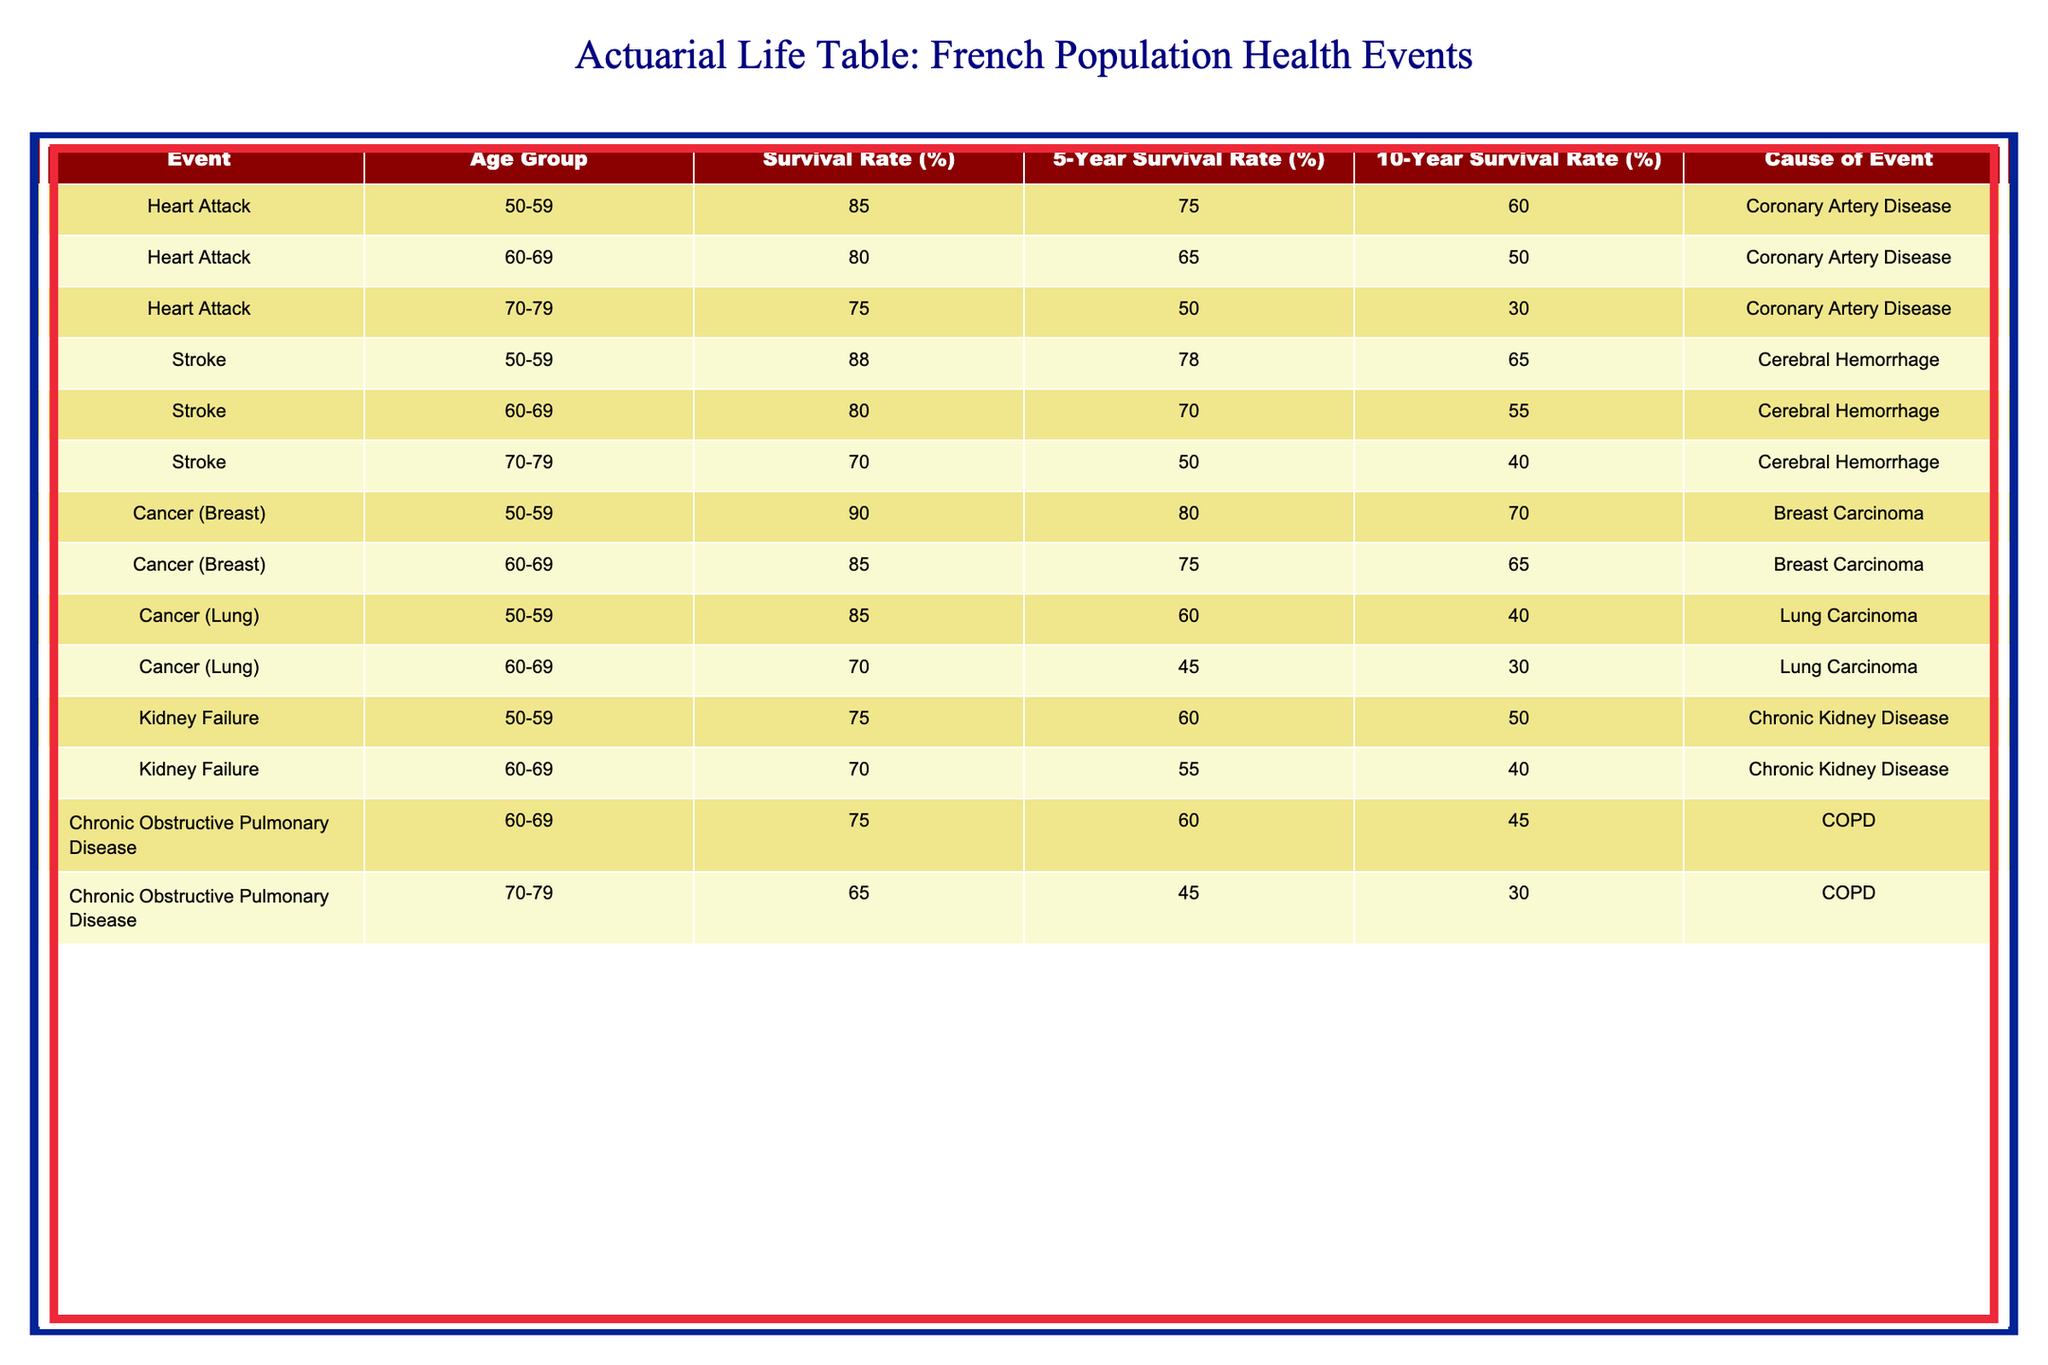What is the survival rate for individuals aged 60-69 after a heart attack? The table shows that the survival rate for individuals aged 60-69 following a heart attack is 80%. This value can be directly retrieved from the relevant row under the "Survival Rate (%)" column.
Answer: 80% What is the 10-year survival rate for individuals aged 50-59 who suffered from lung cancer? According to the table, individuals aged 50-59 who suffered from lung cancer have a 10-year survival rate of 40%. This figure is found in the row dedicated to "Cancer (Lung)" under the 10-Year Survival Rate (%) column related to this age group.
Answer: 40% Is the survival rate for individuals aged 70-79 after a stroke greater than that for kidney failure in the same age group? The survival rate after a stroke for individuals aged 70-79 is 70%, while for kidney failure, it is 65%. Thus, 70% is greater than 65%, making the statement true.
Answer: Yes What is the average 5-year survival rate for individuals aged 50-59 across all health events listed? To find the average 5-year survival rate, we sum the survival rates for age group 50-59: 75% (Heart Attack) + 78% (Stroke) + 80% (Cancer - Breast) + 60% (Cancer - Lung) + 60% (Kidney Failure) = 353%. Dividing this by the number of events (5) gives us an average of 70.6%.
Answer: 70.6% What is the survival rate for individuals aged 60-69 after stroke compared to cancer (breast) in the same age group? The survival rate after a stroke for individuals aged 60-69 is 80%, while the survival rate for breast cancer in the same age group is 85%. 85% is greater than 80%, indicating that breast cancer has a better survival rate compared to a stroke for this age group.
Answer: No How does the 5-year survival rate for individuals aged 70-79 with chronic obstructive pulmonary disease compare to those with a heart attack in the same age group? The 5-year survival rate for individuals aged 70-79 after chronic obstructive pulmonary disease is 45% while for those who had a heart attack it is 50%. Since 45% is less than 50%, the survival rate for chronic obstructive pulmonary disease is lower.
Answer: Lower What health event shows the highest 10-year survival rate for ages 50-59? The health event with the highest 10-year survival rate for individuals aged 50-59 is breast cancer, with a rate of 70%. This can be identified in the comparison of the relevant rows for the age group under the 10-Year Survival Rate (%) column.
Answer: 70% Which age group shows the lowest survival rate for heart attacks? The age group showing the lowest survival rate for heart attacks is 70-79, with a survival rate of 75%. This information is obtained by reviewing the survival rates listed under the heart attack row for each age group.
Answer: 75% 